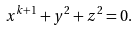Convert formula to latex. <formula><loc_0><loc_0><loc_500><loc_500>x ^ { k + 1 } + y ^ { 2 } + z ^ { 2 } = 0 .</formula> 